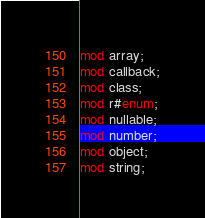<code> <loc_0><loc_0><loc_500><loc_500><_Rust_>
mod array;
mod callback;
mod class;
mod r#enum;
mod nullable;
mod number;
mod object;
mod string;
</code> 